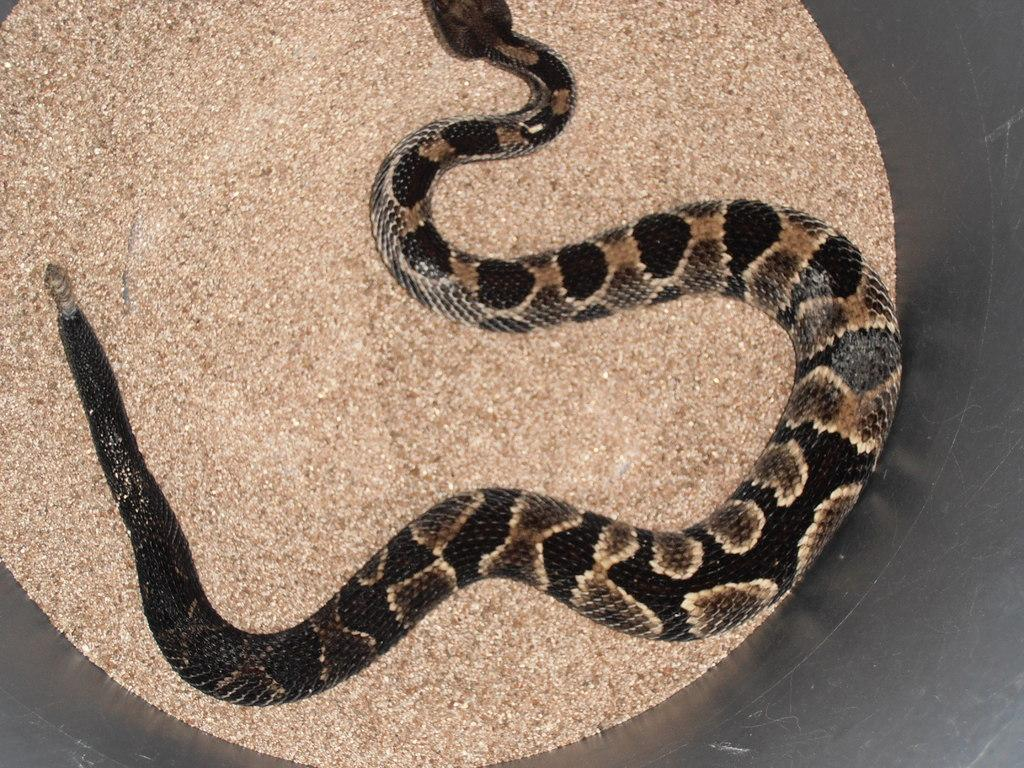What type of animal is present in the image? There is a snake in the image. Where is the snake located in the image? The snake is on the surface. What type of steam is being produced by the snake in the image? There is no steam present in the image, as it features a snake on the surface. 